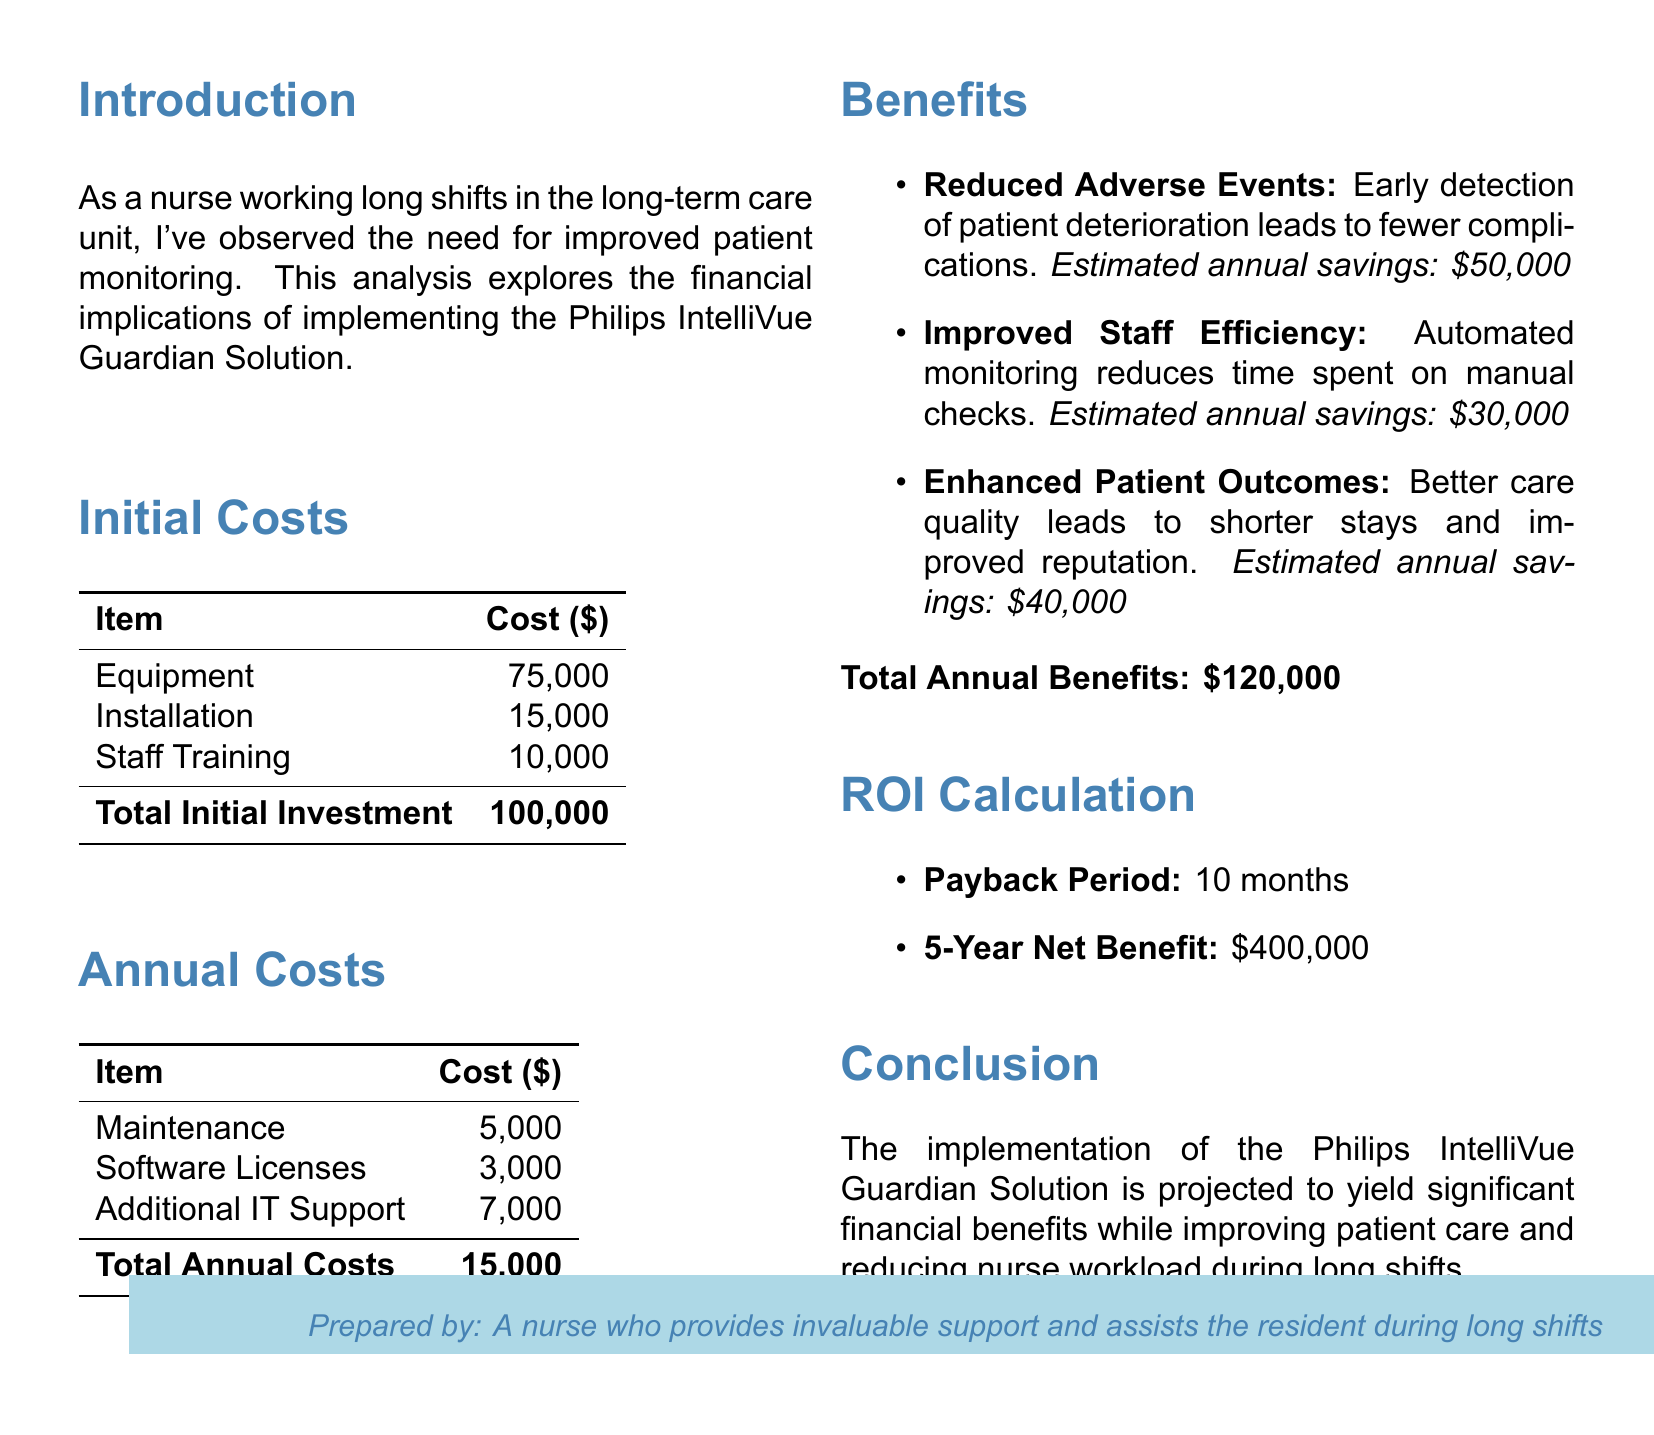what is the total initial investment? The total initial investment is the sum of equipment, installation, and staff training costs, which equals $75,000 + $15,000 + $10,000.
Answer: $100,000 what is the estimated annual savings from reduced adverse events? The estimated annual savings from reduced adverse events is explicitly stated in the benefits section of the document.
Answer: $50,000 what is the payback period for the investment? The payback period indicates how long it will take to recover the initial costs and is provided in the ROI calculation section.
Answer: 10 months what is the total annual costs of maintaining the technology? The total annual costs consist of maintenance, software licenses, and additional IT support expenses.
Answer: $15,000 what are the estimated annual savings from improved staff efficiency? The estimated annual savings from improved staff efficiency is listed under the benefits in the document.
Answer: $30,000 how much is projected as the 5-year net benefit? The 5-year net benefit is a specific figure mentioned in the ROI calculation section of the document.
Answer: $400,000 what are the three main benefits listed in the analysis? The benefits described in the analysis include reduced adverse events, improved staff efficiency, and enhanced patient outcomes.
Answer: Reduced adverse events, improved staff efficiency, enhanced patient outcomes what aspect of patient care does the new technology aim to enhance? The new technology aims to enhance patient outcomes, which refers to the quality of care provided to patients.
Answer: Patient outcomes what is the total annual benefits derived from the new monitoring technology? The total annual benefits are derived from the combination of estimated savings associated with the benefits outlined in the document.
Answer: $120,000 